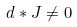Convert formula to latex. <formula><loc_0><loc_0><loc_500><loc_500>d * J \neq 0</formula> 